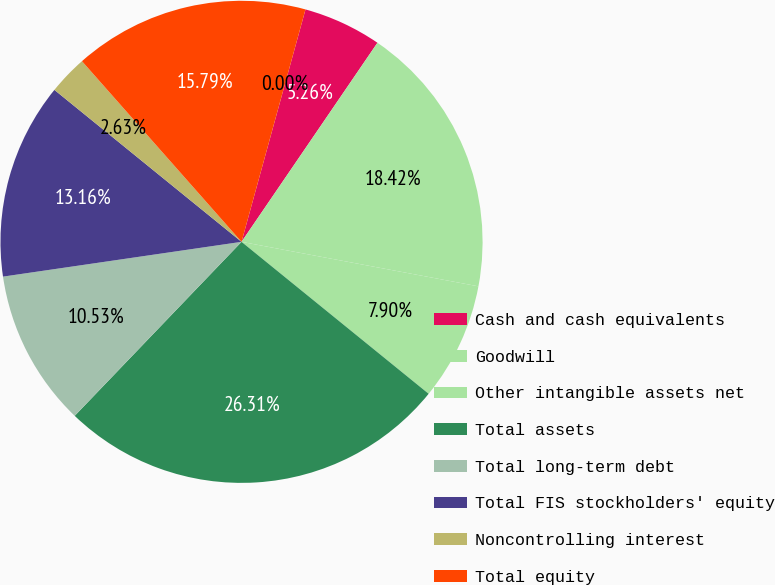Convert chart. <chart><loc_0><loc_0><loc_500><loc_500><pie_chart><fcel>Cash and cash equivalents<fcel>Goodwill<fcel>Other intangible assets net<fcel>Total assets<fcel>Total long-term debt<fcel>Total FIS stockholders' equity<fcel>Noncontrolling interest<fcel>Total equity<fcel>Cash dividends declared per<nl><fcel>5.26%<fcel>18.42%<fcel>7.9%<fcel>26.31%<fcel>10.53%<fcel>13.16%<fcel>2.63%<fcel>15.79%<fcel>0.0%<nl></chart> 